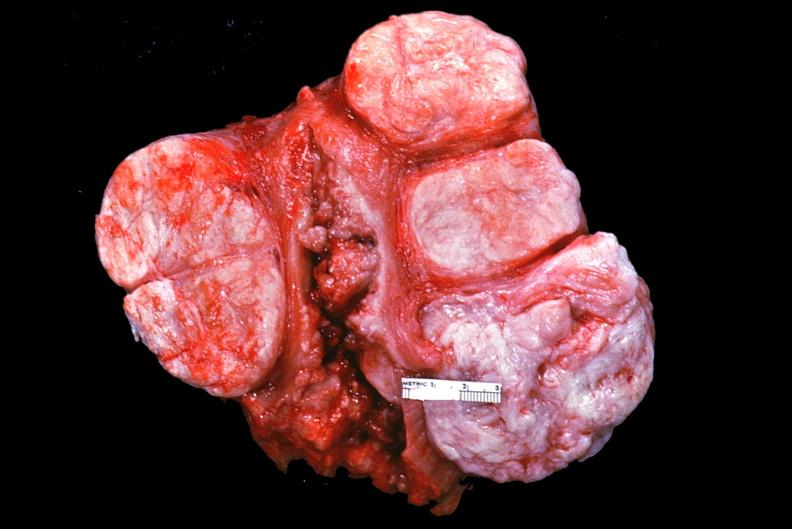does parathyroid show uterus, leiomyomas?
Answer the question using a single word or phrase. No 